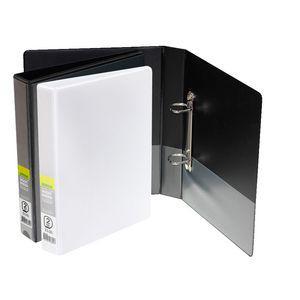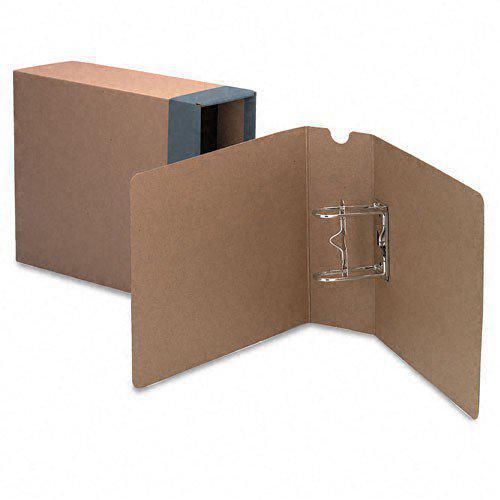The first image is the image on the left, the second image is the image on the right. Evaluate the accuracy of this statement regarding the images: "A binder is on top of a desk.". Is it true? Answer yes or no. No. The first image is the image on the left, the second image is the image on the right. Assess this claim about the two images: "An open ring binder with papers in it lies flat next to at least two upright closed binders.". Correct or not? Answer yes or no. No. 